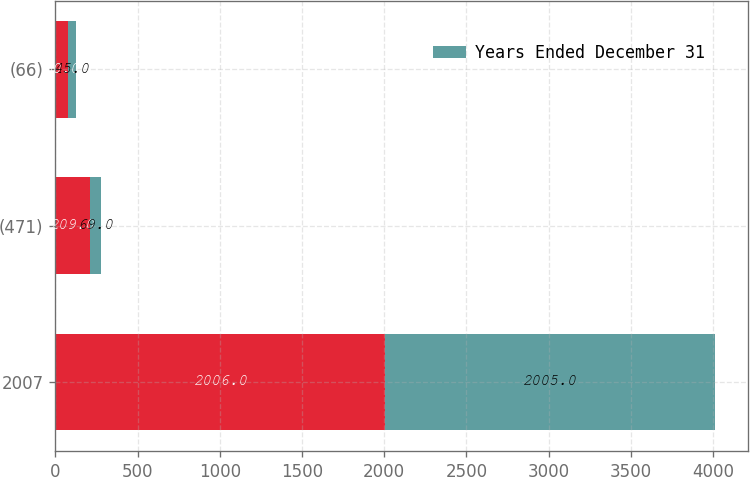Convert chart to OTSL. <chart><loc_0><loc_0><loc_500><loc_500><stacked_bar_chart><ecel><fcel>2007<fcel>(471)<fcel>(66)<nl><fcel>nan<fcel>2006<fcel>209<fcel>80<nl><fcel>Years Ended December 31<fcel>2005<fcel>69<fcel>45<nl></chart> 